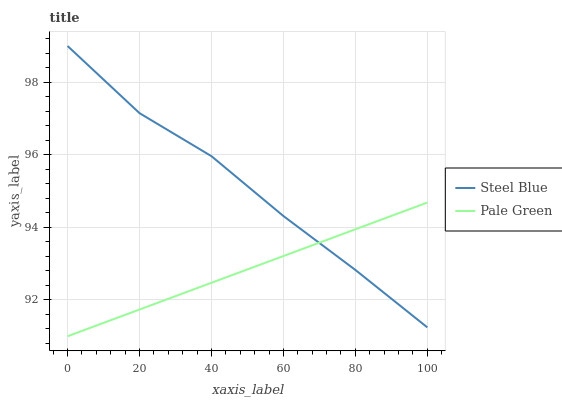Does Steel Blue have the minimum area under the curve?
Answer yes or no. No. Is Steel Blue the smoothest?
Answer yes or no. No. Does Steel Blue have the lowest value?
Answer yes or no. No. 